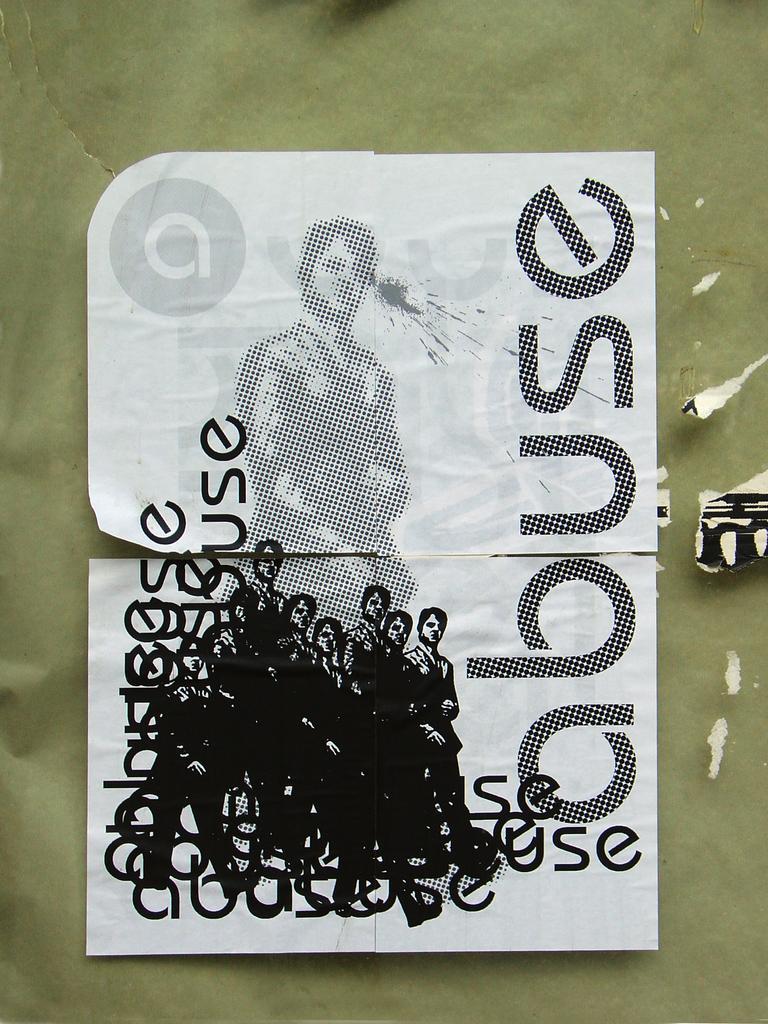Can you describe this image briefly? In this image we can see a poster on which we can see pictures of a person and some text on it. 